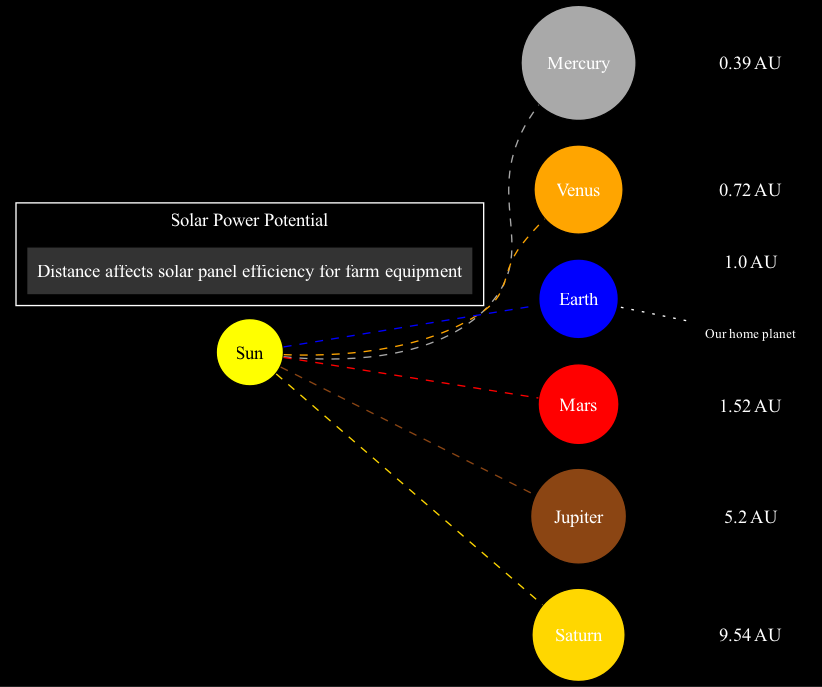What is the distance of Earth from the Sun? According to the diagram, Earth is located at a distance of 1 AU from the Sun. This information is explicitly stated under the Earth node.
Answer: 1 AU Which planet has the shortest orbit distance from the Sun? The diagram indicates that Mercury is positioned at a distance of 0.39 AU from the Sun, making it the closest planet.
Answer: Mercury How many planets are shown in the diagram? The diagram displays a total of six planets: Mercury, Venus, Earth, Mars, Jupiter, and Saturn. This count can be determined by counting the planet nodes in the diagram.
Answer: Six What color represents Jupiter's orbit? Jupiter's orbit is represented by a deep brown color (hex code #8B4513) as mentioned in the data.
Answer: Deep brown Which planet is emphasized as "Our home planet"? The diagram highlights Earth specifically with a note that states "Our home planet" connected with a dotted edge to the Earth node.
Answer: Earth What is the distance of Saturn from the Sun? According to the diagram, Saturn is at a distance of 9.54 AU from the Sun as indicated in the Saturn node details.
Answer: 9.54 AU Which planet is at 1.52 AU from the Sun? The diagram shows that Mars is positioned at a distance of 1.52 AU from the Sun, as indicated in the Mars node.
Answer: Mars How does the distance from the Sun affect solar power potential? The diagram's legend states that solar power potential is influenced by distance, affecting solar panel efficiency for farm equipment. This indicates that further planets may have reduced solar energy potential.
Answer: Distance affects solar panel efficiency 